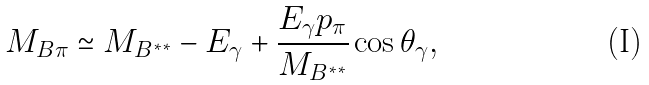Convert formula to latex. <formula><loc_0><loc_0><loc_500><loc_500>M _ { B \pi } \simeq M _ { B ^ { * * } } - E _ { \gamma } + \frac { E _ { \gamma } p _ { \pi } } { M _ { B ^ { * * } } } \cos \theta _ { \gamma } ,</formula> 